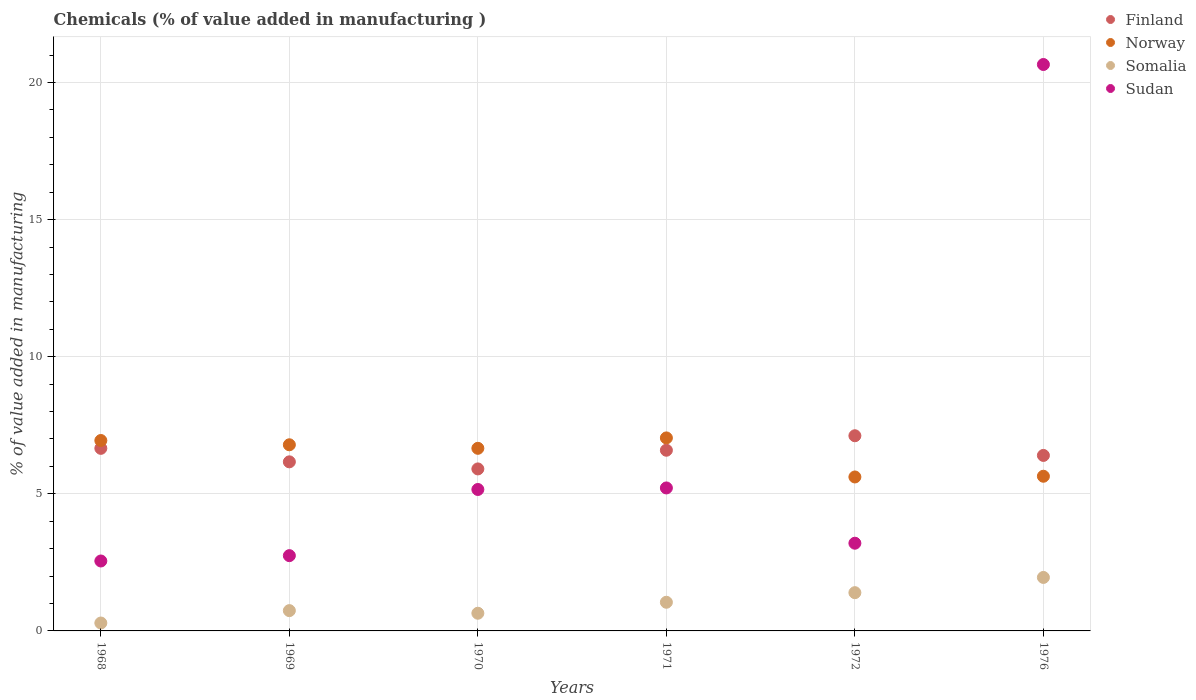How many different coloured dotlines are there?
Provide a succinct answer. 4. Is the number of dotlines equal to the number of legend labels?
Your answer should be compact. Yes. What is the value added in manufacturing chemicals in Finland in 1971?
Your answer should be very brief. 6.59. Across all years, what is the maximum value added in manufacturing chemicals in Norway?
Provide a short and direct response. 7.04. Across all years, what is the minimum value added in manufacturing chemicals in Somalia?
Give a very brief answer. 0.29. In which year was the value added in manufacturing chemicals in Somalia minimum?
Provide a short and direct response. 1968. What is the total value added in manufacturing chemicals in Sudan in the graph?
Ensure brevity in your answer.  39.53. What is the difference between the value added in manufacturing chemicals in Norway in 1970 and that in 1976?
Offer a terse response. 1.02. What is the difference between the value added in manufacturing chemicals in Somalia in 1969 and the value added in manufacturing chemicals in Finland in 1976?
Give a very brief answer. -5.66. What is the average value added in manufacturing chemicals in Finland per year?
Give a very brief answer. 6.47. In the year 1970, what is the difference between the value added in manufacturing chemicals in Finland and value added in manufacturing chemicals in Sudan?
Provide a succinct answer. 0.75. What is the ratio of the value added in manufacturing chemicals in Norway in 1968 to that in 1972?
Provide a succinct answer. 1.24. Is the value added in manufacturing chemicals in Norway in 1968 less than that in 1971?
Keep it short and to the point. Yes. Is the difference between the value added in manufacturing chemicals in Finland in 1968 and 1969 greater than the difference between the value added in manufacturing chemicals in Sudan in 1968 and 1969?
Offer a terse response. Yes. What is the difference between the highest and the second highest value added in manufacturing chemicals in Norway?
Ensure brevity in your answer.  0.09. What is the difference between the highest and the lowest value added in manufacturing chemicals in Sudan?
Make the answer very short. 18.11. Is the sum of the value added in manufacturing chemicals in Norway in 1970 and 1971 greater than the maximum value added in manufacturing chemicals in Sudan across all years?
Make the answer very short. No. Is it the case that in every year, the sum of the value added in manufacturing chemicals in Finland and value added in manufacturing chemicals in Norway  is greater than the sum of value added in manufacturing chemicals in Somalia and value added in manufacturing chemicals in Sudan?
Your response must be concise. Yes. Is it the case that in every year, the sum of the value added in manufacturing chemicals in Sudan and value added in manufacturing chemicals in Norway  is greater than the value added in manufacturing chemicals in Somalia?
Your answer should be compact. Yes. Does the value added in manufacturing chemicals in Norway monotonically increase over the years?
Keep it short and to the point. No. Is the value added in manufacturing chemicals in Sudan strictly less than the value added in manufacturing chemicals in Finland over the years?
Your response must be concise. No. How many dotlines are there?
Provide a short and direct response. 4. Does the graph contain grids?
Give a very brief answer. Yes. How many legend labels are there?
Provide a short and direct response. 4. What is the title of the graph?
Offer a terse response. Chemicals (% of value added in manufacturing ). Does "Brazil" appear as one of the legend labels in the graph?
Make the answer very short. No. What is the label or title of the X-axis?
Offer a very short reply. Years. What is the label or title of the Y-axis?
Your answer should be compact. % of value added in manufacturing. What is the % of value added in manufacturing in Finland in 1968?
Offer a very short reply. 6.66. What is the % of value added in manufacturing in Norway in 1968?
Offer a terse response. 6.94. What is the % of value added in manufacturing of Somalia in 1968?
Your response must be concise. 0.29. What is the % of value added in manufacturing in Sudan in 1968?
Ensure brevity in your answer.  2.55. What is the % of value added in manufacturing in Finland in 1969?
Make the answer very short. 6.17. What is the % of value added in manufacturing in Norway in 1969?
Your response must be concise. 6.79. What is the % of value added in manufacturing of Somalia in 1969?
Your answer should be compact. 0.74. What is the % of value added in manufacturing of Sudan in 1969?
Give a very brief answer. 2.75. What is the % of value added in manufacturing of Finland in 1970?
Provide a short and direct response. 5.91. What is the % of value added in manufacturing of Norway in 1970?
Provide a succinct answer. 6.66. What is the % of value added in manufacturing in Somalia in 1970?
Your answer should be compact. 0.64. What is the % of value added in manufacturing in Sudan in 1970?
Your answer should be very brief. 5.16. What is the % of value added in manufacturing in Finland in 1971?
Ensure brevity in your answer.  6.59. What is the % of value added in manufacturing of Norway in 1971?
Your answer should be compact. 7.04. What is the % of value added in manufacturing of Somalia in 1971?
Provide a succinct answer. 1.05. What is the % of value added in manufacturing in Sudan in 1971?
Provide a short and direct response. 5.21. What is the % of value added in manufacturing in Finland in 1972?
Keep it short and to the point. 7.12. What is the % of value added in manufacturing in Norway in 1972?
Offer a terse response. 5.61. What is the % of value added in manufacturing of Somalia in 1972?
Your response must be concise. 1.4. What is the % of value added in manufacturing in Sudan in 1972?
Offer a terse response. 3.2. What is the % of value added in manufacturing in Finland in 1976?
Provide a short and direct response. 6.4. What is the % of value added in manufacturing in Norway in 1976?
Your answer should be very brief. 5.64. What is the % of value added in manufacturing in Somalia in 1976?
Offer a very short reply. 1.95. What is the % of value added in manufacturing of Sudan in 1976?
Make the answer very short. 20.66. Across all years, what is the maximum % of value added in manufacturing in Finland?
Your response must be concise. 7.12. Across all years, what is the maximum % of value added in manufacturing of Norway?
Give a very brief answer. 7.04. Across all years, what is the maximum % of value added in manufacturing of Somalia?
Make the answer very short. 1.95. Across all years, what is the maximum % of value added in manufacturing of Sudan?
Offer a terse response. 20.66. Across all years, what is the minimum % of value added in manufacturing in Finland?
Keep it short and to the point. 5.91. Across all years, what is the minimum % of value added in manufacturing in Norway?
Your answer should be very brief. 5.61. Across all years, what is the minimum % of value added in manufacturing in Somalia?
Provide a succinct answer. 0.29. Across all years, what is the minimum % of value added in manufacturing of Sudan?
Provide a succinct answer. 2.55. What is the total % of value added in manufacturing in Finland in the graph?
Provide a succinct answer. 38.84. What is the total % of value added in manufacturing in Norway in the graph?
Your response must be concise. 38.69. What is the total % of value added in manufacturing in Somalia in the graph?
Keep it short and to the point. 6.06. What is the total % of value added in manufacturing of Sudan in the graph?
Ensure brevity in your answer.  39.53. What is the difference between the % of value added in manufacturing of Finland in 1968 and that in 1969?
Your response must be concise. 0.49. What is the difference between the % of value added in manufacturing in Norway in 1968 and that in 1969?
Your answer should be compact. 0.16. What is the difference between the % of value added in manufacturing of Somalia in 1968 and that in 1969?
Your response must be concise. -0.45. What is the difference between the % of value added in manufacturing in Sudan in 1968 and that in 1969?
Your answer should be compact. -0.19. What is the difference between the % of value added in manufacturing in Finland in 1968 and that in 1970?
Offer a terse response. 0.75. What is the difference between the % of value added in manufacturing in Norway in 1968 and that in 1970?
Your answer should be compact. 0.28. What is the difference between the % of value added in manufacturing in Somalia in 1968 and that in 1970?
Offer a very short reply. -0.36. What is the difference between the % of value added in manufacturing in Sudan in 1968 and that in 1970?
Keep it short and to the point. -2.61. What is the difference between the % of value added in manufacturing of Finland in 1968 and that in 1971?
Give a very brief answer. 0.07. What is the difference between the % of value added in manufacturing in Norway in 1968 and that in 1971?
Provide a short and direct response. -0.09. What is the difference between the % of value added in manufacturing in Somalia in 1968 and that in 1971?
Offer a very short reply. -0.76. What is the difference between the % of value added in manufacturing of Sudan in 1968 and that in 1971?
Your answer should be compact. -2.66. What is the difference between the % of value added in manufacturing of Finland in 1968 and that in 1972?
Your response must be concise. -0.46. What is the difference between the % of value added in manufacturing of Norway in 1968 and that in 1972?
Ensure brevity in your answer.  1.33. What is the difference between the % of value added in manufacturing in Somalia in 1968 and that in 1972?
Provide a succinct answer. -1.11. What is the difference between the % of value added in manufacturing in Sudan in 1968 and that in 1972?
Give a very brief answer. -0.65. What is the difference between the % of value added in manufacturing of Finland in 1968 and that in 1976?
Your answer should be compact. 0.26. What is the difference between the % of value added in manufacturing of Norway in 1968 and that in 1976?
Your answer should be compact. 1.3. What is the difference between the % of value added in manufacturing in Somalia in 1968 and that in 1976?
Your answer should be very brief. -1.66. What is the difference between the % of value added in manufacturing of Sudan in 1968 and that in 1976?
Your answer should be very brief. -18.11. What is the difference between the % of value added in manufacturing in Finland in 1969 and that in 1970?
Ensure brevity in your answer.  0.26. What is the difference between the % of value added in manufacturing in Norway in 1969 and that in 1970?
Keep it short and to the point. 0.13. What is the difference between the % of value added in manufacturing in Somalia in 1969 and that in 1970?
Ensure brevity in your answer.  0.1. What is the difference between the % of value added in manufacturing of Sudan in 1969 and that in 1970?
Make the answer very short. -2.41. What is the difference between the % of value added in manufacturing of Finland in 1969 and that in 1971?
Ensure brevity in your answer.  -0.42. What is the difference between the % of value added in manufacturing in Norway in 1969 and that in 1971?
Offer a terse response. -0.25. What is the difference between the % of value added in manufacturing in Somalia in 1969 and that in 1971?
Ensure brevity in your answer.  -0.3. What is the difference between the % of value added in manufacturing in Sudan in 1969 and that in 1971?
Keep it short and to the point. -2.47. What is the difference between the % of value added in manufacturing in Finland in 1969 and that in 1972?
Make the answer very short. -0.95. What is the difference between the % of value added in manufacturing of Norway in 1969 and that in 1972?
Provide a short and direct response. 1.17. What is the difference between the % of value added in manufacturing of Somalia in 1969 and that in 1972?
Ensure brevity in your answer.  -0.66. What is the difference between the % of value added in manufacturing of Sudan in 1969 and that in 1972?
Keep it short and to the point. -0.45. What is the difference between the % of value added in manufacturing in Finland in 1969 and that in 1976?
Your answer should be very brief. -0.23. What is the difference between the % of value added in manufacturing of Norway in 1969 and that in 1976?
Offer a very short reply. 1.15. What is the difference between the % of value added in manufacturing of Somalia in 1969 and that in 1976?
Offer a terse response. -1.21. What is the difference between the % of value added in manufacturing in Sudan in 1969 and that in 1976?
Keep it short and to the point. -17.91. What is the difference between the % of value added in manufacturing in Finland in 1970 and that in 1971?
Your answer should be compact. -0.68. What is the difference between the % of value added in manufacturing of Norway in 1970 and that in 1971?
Keep it short and to the point. -0.38. What is the difference between the % of value added in manufacturing in Somalia in 1970 and that in 1971?
Your answer should be compact. -0.4. What is the difference between the % of value added in manufacturing of Sudan in 1970 and that in 1971?
Your answer should be very brief. -0.06. What is the difference between the % of value added in manufacturing in Finland in 1970 and that in 1972?
Offer a very short reply. -1.21. What is the difference between the % of value added in manufacturing of Norway in 1970 and that in 1972?
Give a very brief answer. 1.05. What is the difference between the % of value added in manufacturing of Somalia in 1970 and that in 1972?
Ensure brevity in your answer.  -0.75. What is the difference between the % of value added in manufacturing of Sudan in 1970 and that in 1972?
Provide a succinct answer. 1.96. What is the difference between the % of value added in manufacturing of Finland in 1970 and that in 1976?
Your response must be concise. -0.49. What is the difference between the % of value added in manufacturing in Norway in 1970 and that in 1976?
Keep it short and to the point. 1.02. What is the difference between the % of value added in manufacturing in Somalia in 1970 and that in 1976?
Your response must be concise. -1.31. What is the difference between the % of value added in manufacturing of Sudan in 1970 and that in 1976?
Make the answer very short. -15.5. What is the difference between the % of value added in manufacturing in Finland in 1971 and that in 1972?
Provide a short and direct response. -0.53. What is the difference between the % of value added in manufacturing of Norway in 1971 and that in 1972?
Offer a very short reply. 1.42. What is the difference between the % of value added in manufacturing of Somalia in 1971 and that in 1972?
Provide a short and direct response. -0.35. What is the difference between the % of value added in manufacturing of Sudan in 1971 and that in 1972?
Make the answer very short. 2.02. What is the difference between the % of value added in manufacturing in Finland in 1971 and that in 1976?
Keep it short and to the point. 0.19. What is the difference between the % of value added in manufacturing in Norway in 1971 and that in 1976?
Make the answer very short. 1.4. What is the difference between the % of value added in manufacturing in Somalia in 1971 and that in 1976?
Provide a short and direct response. -0.91. What is the difference between the % of value added in manufacturing of Sudan in 1971 and that in 1976?
Make the answer very short. -15.44. What is the difference between the % of value added in manufacturing of Finland in 1972 and that in 1976?
Offer a very short reply. 0.72. What is the difference between the % of value added in manufacturing of Norway in 1972 and that in 1976?
Provide a short and direct response. -0.03. What is the difference between the % of value added in manufacturing in Somalia in 1972 and that in 1976?
Keep it short and to the point. -0.56. What is the difference between the % of value added in manufacturing of Sudan in 1972 and that in 1976?
Your answer should be compact. -17.46. What is the difference between the % of value added in manufacturing in Finland in 1968 and the % of value added in manufacturing in Norway in 1969?
Your answer should be very brief. -0.13. What is the difference between the % of value added in manufacturing of Finland in 1968 and the % of value added in manufacturing of Somalia in 1969?
Offer a very short reply. 5.92. What is the difference between the % of value added in manufacturing of Finland in 1968 and the % of value added in manufacturing of Sudan in 1969?
Your answer should be very brief. 3.91. What is the difference between the % of value added in manufacturing in Norway in 1968 and the % of value added in manufacturing in Somalia in 1969?
Give a very brief answer. 6.2. What is the difference between the % of value added in manufacturing of Norway in 1968 and the % of value added in manufacturing of Sudan in 1969?
Your answer should be compact. 4.2. What is the difference between the % of value added in manufacturing of Somalia in 1968 and the % of value added in manufacturing of Sudan in 1969?
Make the answer very short. -2.46. What is the difference between the % of value added in manufacturing of Finland in 1968 and the % of value added in manufacturing of Norway in 1970?
Ensure brevity in your answer.  -0. What is the difference between the % of value added in manufacturing of Finland in 1968 and the % of value added in manufacturing of Somalia in 1970?
Ensure brevity in your answer.  6.01. What is the difference between the % of value added in manufacturing of Finland in 1968 and the % of value added in manufacturing of Sudan in 1970?
Your response must be concise. 1.5. What is the difference between the % of value added in manufacturing of Norway in 1968 and the % of value added in manufacturing of Somalia in 1970?
Provide a succinct answer. 6.3. What is the difference between the % of value added in manufacturing in Norway in 1968 and the % of value added in manufacturing in Sudan in 1970?
Provide a succinct answer. 1.79. What is the difference between the % of value added in manufacturing in Somalia in 1968 and the % of value added in manufacturing in Sudan in 1970?
Provide a succinct answer. -4.87. What is the difference between the % of value added in manufacturing in Finland in 1968 and the % of value added in manufacturing in Norway in 1971?
Offer a very short reply. -0.38. What is the difference between the % of value added in manufacturing in Finland in 1968 and the % of value added in manufacturing in Somalia in 1971?
Make the answer very short. 5.61. What is the difference between the % of value added in manufacturing of Finland in 1968 and the % of value added in manufacturing of Sudan in 1971?
Ensure brevity in your answer.  1.44. What is the difference between the % of value added in manufacturing in Norway in 1968 and the % of value added in manufacturing in Somalia in 1971?
Make the answer very short. 5.9. What is the difference between the % of value added in manufacturing in Norway in 1968 and the % of value added in manufacturing in Sudan in 1971?
Offer a very short reply. 1.73. What is the difference between the % of value added in manufacturing in Somalia in 1968 and the % of value added in manufacturing in Sudan in 1971?
Provide a short and direct response. -4.93. What is the difference between the % of value added in manufacturing in Finland in 1968 and the % of value added in manufacturing in Norway in 1972?
Give a very brief answer. 1.04. What is the difference between the % of value added in manufacturing in Finland in 1968 and the % of value added in manufacturing in Somalia in 1972?
Offer a very short reply. 5.26. What is the difference between the % of value added in manufacturing of Finland in 1968 and the % of value added in manufacturing of Sudan in 1972?
Your answer should be compact. 3.46. What is the difference between the % of value added in manufacturing of Norway in 1968 and the % of value added in manufacturing of Somalia in 1972?
Provide a succinct answer. 5.55. What is the difference between the % of value added in manufacturing in Norway in 1968 and the % of value added in manufacturing in Sudan in 1972?
Offer a terse response. 3.75. What is the difference between the % of value added in manufacturing in Somalia in 1968 and the % of value added in manufacturing in Sudan in 1972?
Keep it short and to the point. -2.91. What is the difference between the % of value added in manufacturing in Finland in 1968 and the % of value added in manufacturing in Norway in 1976?
Offer a very short reply. 1.02. What is the difference between the % of value added in manufacturing of Finland in 1968 and the % of value added in manufacturing of Somalia in 1976?
Give a very brief answer. 4.71. What is the difference between the % of value added in manufacturing of Finland in 1968 and the % of value added in manufacturing of Sudan in 1976?
Your answer should be very brief. -14. What is the difference between the % of value added in manufacturing in Norway in 1968 and the % of value added in manufacturing in Somalia in 1976?
Give a very brief answer. 4.99. What is the difference between the % of value added in manufacturing in Norway in 1968 and the % of value added in manufacturing in Sudan in 1976?
Offer a terse response. -13.71. What is the difference between the % of value added in manufacturing in Somalia in 1968 and the % of value added in manufacturing in Sudan in 1976?
Keep it short and to the point. -20.37. What is the difference between the % of value added in manufacturing of Finland in 1969 and the % of value added in manufacturing of Norway in 1970?
Give a very brief answer. -0.49. What is the difference between the % of value added in manufacturing in Finland in 1969 and the % of value added in manufacturing in Somalia in 1970?
Give a very brief answer. 5.52. What is the difference between the % of value added in manufacturing of Norway in 1969 and the % of value added in manufacturing of Somalia in 1970?
Your answer should be very brief. 6.14. What is the difference between the % of value added in manufacturing in Norway in 1969 and the % of value added in manufacturing in Sudan in 1970?
Your answer should be very brief. 1.63. What is the difference between the % of value added in manufacturing in Somalia in 1969 and the % of value added in manufacturing in Sudan in 1970?
Give a very brief answer. -4.42. What is the difference between the % of value added in manufacturing in Finland in 1969 and the % of value added in manufacturing in Norway in 1971?
Provide a short and direct response. -0.87. What is the difference between the % of value added in manufacturing in Finland in 1969 and the % of value added in manufacturing in Somalia in 1971?
Give a very brief answer. 5.12. What is the difference between the % of value added in manufacturing in Finland in 1969 and the % of value added in manufacturing in Sudan in 1971?
Ensure brevity in your answer.  0.95. What is the difference between the % of value added in manufacturing in Norway in 1969 and the % of value added in manufacturing in Somalia in 1971?
Offer a terse response. 5.74. What is the difference between the % of value added in manufacturing in Norway in 1969 and the % of value added in manufacturing in Sudan in 1971?
Offer a very short reply. 1.57. What is the difference between the % of value added in manufacturing of Somalia in 1969 and the % of value added in manufacturing of Sudan in 1971?
Offer a terse response. -4.47. What is the difference between the % of value added in manufacturing in Finland in 1969 and the % of value added in manufacturing in Norway in 1972?
Offer a very short reply. 0.55. What is the difference between the % of value added in manufacturing in Finland in 1969 and the % of value added in manufacturing in Somalia in 1972?
Ensure brevity in your answer.  4.77. What is the difference between the % of value added in manufacturing of Finland in 1969 and the % of value added in manufacturing of Sudan in 1972?
Provide a short and direct response. 2.97. What is the difference between the % of value added in manufacturing of Norway in 1969 and the % of value added in manufacturing of Somalia in 1972?
Make the answer very short. 5.39. What is the difference between the % of value added in manufacturing in Norway in 1969 and the % of value added in manufacturing in Sudan in 1972?
Ensure brevity in your answer.  3.59. What is the difference between the % of value added in manufacturing of Somalia in 1969 and the % of value added in manufacturing of Sudan in 1972?
Your answer should be very brief. -2.46. What is the difference between the % of value added in manufacturing in Finland in 1969 and the % of value added in manufacturing in Norway in 1976?
Your answer should be very brief. 0.53. What is the difference between the % of value added in manufacturing of Finland in 1969 and the % of value added in manufacturing of Somalia in 1976?
Make the answer very short. 4.22. What is the difference between the % of value added in manufacturing of Finland in 1969 and the % of value added in manufacturing of Sudan in 1976?
Ensure brevity in your answer.  -14.49. What is the difference between the % of value added in manufacturing of Norway in 1969 and the % of value added in manufacturing of Somalia in 1976?
Your answer should be very brief. 4.84. What is the difference between the % of value added in manufacturing in Norway in 1969 and the % of value added in manufacturing in Sudan in 1976?
Give a very brief answer. -13.87. What is the difference between the % of value added in manufacturing of Somalia in 1969 and the % of value added in manufacturing of Sudan in 1976?
Provide a short and direct response. -19.92. What is the difference between the % of value added in manufacturing of Finland in 1970 and the % of value added in manufacturing of Norway in 1971?
Make the answer very short. -1.13. What is the difference between the % of value added in manufacturing of Finland in 1970 and the % of value added in manufacturing of Somalia in 1971?
Provide a succinct answer. 4.86. What is the difference between the % of value added in manufacturing in Finland in 1970 and the % of value added in manufacturing in Sudan in 1971?
Provide a succinct answer. 0.69. What is the difference between the % of value added in manufacturing in Norway in 1970 and the % of value added in manufacturing in Somalia in 1971?
Offer a very short reply. 5.61. What is the difference between the % of value added in manufacturing in Norway in 1970 and the % of value added in manufacturing in Sudan in 1971?
Your answer should be very brief. 1.45. What is the difference between the % of value added in manufacturing of Somalia in 1970 and the % of value added in manufacturing of Sudan in 1971?
Keep it short and to the point. -4.57. What is the difference between the % of value added in manufacturing in Finland in 1970 and the % of value added in manufacturing in Norway in 1972?
Ensure brevity in your answer.  0.29. What is the difference between the % of value added in manufacturing of Finland in 1970 and the % of value added in manufacturing of Somalia in 1972?
Your answer should be very brief. 4.51. What is the difference between the % of value added in manufacturing of Finland in 1970 and the % of value added in manufacturing of Sudan in 1972?
Ensure brevity in your answer.  2.71. What is the difference between the % of value added in manufacturing of Norway in 1970 and the % of value added in manufacturing of Somalia in 1972?
Offer a very short reply. 5.26. What is the difference between the % of value added in manufacturing of Norway in 1970 and the % of value added in manufacturing of Sudan in 1972?
Make the answer very short. 3.46. What is the difference between the % of value added in manufacturing in Somalia in 1970 and the % of value added in manufacturing in Sudan in 1972?
Ensure brevity in your answer.  -2.55. What is the difference between the % of value added in manufacturing in Finland in 1970 and the % of value added in manufacturing in Norway in 1976?
Ensure brevity in your answer.  0.27. What is the difference between the % of value added in manufacturing of Finland in 1970 and the % of value added in manufacturing of Somalia in 1976?
Your response must be concise. 3.96. What is the difference between the % of value added in manufacturing of Finland in 1970 and the % of value added in manufacturing of Sudan in 1976?
Provide a succinct answer. -14.75. What is the difference between the % of value added in manufacturing in Norway in 1970 and the % of value added in manufacturing in Somalia in 1976?
Ensure brevity in your answer.  4.71. What is the difference between the % of value added in manufacturing in Norway in 1970 and the % of value added in manufacturing in Sudan in 1976?
Provide a short and direct response. -14. What is the difference between the % of value added in manufacturing of Somalia in 1970 and the % of value added in manufacturing of Sudan in 1976?
Your response must be concise. -20.01. What is the difference between the % of value added in manufacturing of Finland in 1971 and the % of value added in manufacturing of Somalia in 1972?
Provide a short and direct response. 5.19. What is the difference between the % of value added in manufacturing in Finland in 1971 and the % of value added in manufacturing in Sudan in 1972?
Your response must be concise. 3.39. What is the difference between the % of value added in manufacturing in Norway in 1971 and the % of value added in manufacturing in Somalia in 1972?
Your answer should be compact. 5.64. What is the difference between the % of value added in manufacturing of Norway in 1971 and the % of value added in manufacturing of Sudan in 1972?
Make the answer very short. 3.84. What is the difference between the % of value added in manufacturing of Somalia in 1971 and the % of value added in manufacturing of Sudan in 1972?
Provide a short and direct response. -2.15. What is the difference between the % of value added in manufacturing in Finland in 1971 and the % of value added in manufacturing in Norway in 1976?
Offer a very short reply. 0.95. What is the difference between the % of value added in manufacturing in Finland in 1971 and the % of value added in manufacturing in Somalia in 1976?
Your response must be concise. 4.64. What is the difference between the % of value added in manufacturing in Finland in 1971 and the % of value added in manufacturing in Sudan in 1976?
Make the answer very short. -14.07. What is the difference between the % of value added in manufacturing in Norway in 1971 and the % of value added in manufacturing in Somalia in 1976?
Make the answer very short. 5.09. What is the difference between the % of value added in manufacturing of Norway in 1971 and the % of value added in manufacturing of Sudan in 1976?
Keep it short and to the point. -13.62. What is the difference between the % of value added in manufacturing of Somalia in 1971 and the % of value added in manufacturing of Sudan in 1976?
Offer a very short reply. -19.61. What is the difference between the % of value added in manufacturing in Finland in 1972 and the % of value added in manufacturing in Norway in 1976?
Provide a short and direct response. 1.48. What is the difference between the % of value added in manufacturing of Finland in 1972 and the % of value added in manufacturing of Somalia in 1976?
Provide a short and direct response. 5.17. What is the difference between the % of value added in manufacturing in Finland in 1972 and the % of value added in manufacturing in Sudan in 1976?
Provide a short and direct response. -13.54. What is the difference between the % of value added in manufacturing in Norway in 1972 and the % of value added in manufacturing in Somalia in 1976?
Offer a terse response. 3.66. What is the difference between the % of value added in manufacturing of Norway in 1972 and the % of value added in manufacturing of Sudan in 1976?
Ensure brevity in your answer.  -15.04. What is the difference between the % of value added in manufacturing in Somalia in 1972 and the % of value added in manufacturing in Sudan in 1976?
Your answer should be very brief. -19.26. What is the average % of value added in manufacturing in Finland per year?
Offer a terse response. 6.47. What is the average % of value added in manufacturing of Norway per year?
Give a very brief answer. 6.45. What is the average % of value added in manufacturing of Somalia per year?
Give a very brief answer. 1.01. What is the average % of value added in manufacturing in Sudan per year?
Provide a succinct answer. 6.59. In the year 1968, what is the difference between the % of value added in manufacturing in Finland and % of value added in manufacturing in Norway?
Your response must be concise. -0.29. In the year 1968, what is the difference between the % of value added in manufacturing of Finland and % of value added in manufacturing of Somalia?
Make the answer very short. 6.37. In the year 1968, what is the difference between the % of value added in manufacturing of Finland and % of value added in manufacturing of Sudan?
Ensure brevity in your answer.  4.11. In the year 1968, what is the difference between the % of value added in manufacturing of Norway and % of value added in manufacturing of Somalia?
Provide a succinct answer. 6.66. In the year 1968, what is the difference between the % of value added in manufacturing in Norway and % of value added in manufacturing in Sudan?
Provide a short and direct response. 4.39. In the year 1968, what is the difference between the % of value added in manufacturing in Somalia and % of value added in manufacturing in Sudan?
Give a very brief answer. -2.26. In the year 1969, what is the difference between the % of value added in manufacturing of Finland and % of value added in manufacturing of Norway?
Offer a terse response. -0.62. In the year 1969, what is the difference between the % of value added in manufacturing of Finland and % of value added in manufacturing of Somalia?
Your response must be concise. 5.43. In the year 1969, what is the difference between the % of value added in manufacturing in Finland and % of value added in manufacturing in Sudan?
Provide a short and direct response. 3.42. In the year 1969, what is the difference between the % of value added in manufacturing of Norway and % of value added in manufacturing of Somalia?
Your response must be concise. 6.05. In the year 1969, what is the difference between the % of value added in manufacturing in Norway and % of value added in manufacturing in Sudan?
Make the answer very short. 4.04. In the year 1969, what is the difference between the % of value added in manufacturing of Somalia and % of value added in manufacturing of Sudan?
Provide a succinct answer. -2.01. In the year 1970, what is the difference between the % of value added in manufacturing in Finland and % of value added in manufacturing in Norway?
Ensure brevity in your answer.  -0.75. In the year 1970, what is the difference between the % of value added in manufacturing of Finland and % of value added in manufacturing of Somalia?
Give a very brief answer. 5.26. In the year 1970, what is the difference between the % of value added in manufacturing in Finland and % of value added in manufacturing in Sudan?
Your answer should be very brief. 0.75. In the year 1970, what is the difference between the % of value added in manufacturing in Norway and % of value added in manufacturing in Somalia?
Your response must be concise. 6.01. In the year 1970, what is the difference between the % of value added in manufacturing of Norway and % of value added in manufacturing of Sudan?
Provide a short and direct response. 1.5. In the year 1970, what is the difference between the % of value added in manufacturing of Somalia and % of value added in manufacturing of Sudan?
Make the answer very short. -4.51. In the year 1971, what is the difference between the % of value added in manufacturing of Finland and % of value added in manufacturing of Norway?
Give a very brief answer. -0.45. In the year 1971, what is the difference between the % of value added in manufacturing of Finland and % of value added in manufacturing of Somalia?
Your answer should be compact. 5.54. In the year 1971, what is the difference between the % of value added in manufacturing in Finland and % of value added in manufacturing in Sudan?
Give a very brief answer. 1.38. In the year 1971, what is the difference between the % of value added in manufacturing in Norway and % of value added in manufacturing in Somalia?
Your answer should be very brief. 5.99. In the year 1971, what is the difference between the % of value added in manufacturing of Norway and % of value added in manufacturing of Sudan?
Provide a succinct answer. 1.82. In the year 1971, what is the difference between the % of value added in manufacturing of Somalia and % of value added in manufacturing of Sudan?
Give a very brief answer. -4.17. In the year 1972, what is the difference between the % of value added in manufacturing in Finland and % of value added in manufacturing in Norway?
Your response must be concise. 1.5. In the year 1972, what is the difference between the % of value added in manufacturing in Finland and % of value added in manufacturing in Somalia?
Your response must be concise. 5.72. In the year 1972, what is the difference between the % of value added in manufacturing in Finland and % of value added in manufacturing in Sudan?
Offer a terse response. 3.92. In the year 1972, what is the difference between the % of value added in manufacturing in Norway and % of value added in manufacturing in Somalia?
Ensure brevity in your answer.  4.22. In the year 1972, what is the difference between the % of value added in manufacturing in Norway and % of value added in manufacturing in Sudan?
Make the answer very short. 2.42. In the year 1972, what is the difference between the % of value added in manufacturing of Somalia and % of value added in manufacturing of Sudan?
Your response must be concise. -1.8. In the year 1976, what is the difference between the % of value added in manufacturing of Finland and % of value added in manufacturing of Norway?
Your answer should be compact. 0.76. In the year 1976, what is the difference between the % of value added in manufacturing of Finland and % of value added in manufacturing of Somalia?
Offer a very short reply. 4.45. In the year 1976, what is the difference between the % of value added in manufacturing in Finland and % of value added in manufacturing in Sudan?
Your answer should be very brief. -14.26. In the year 1976, what is the difference between the % of value added in manufacturing of Norway and % of value added in manufacturing of Somalia?
Your answer should be very brief. 3.69. In the year 1976, what is the difference between the % of value added in manufacturing of Norway and % of value added in manufacturing of Sudan?
Provide a succinct answer. -15.02. In the year 1976, what is the difference between the % of value added in manufacturing in Somalia and % of value added in manufacturing in Sudan?
Your answer should be very brief. -18.71. What is the ratio of the % of value added in manufacturing of Finland in 1968 to that in 1969?
Provide a succinct answer. 1.08. What is the ratio of the % of value added in manufacturing in Norway in 1968 to that in 1969?
Provide a short and direct response. 1.02. What is the ratio of the % of value added in manufacturing of Somalia in 1968 to that in 1969?
Give a very brief answer. 0.39. What is the ratio of the % of value added in manufacturing in Sudan in 1968 to that in 1969?
Provide a succinct answer. 0.93. What is the ratio of the % of value added in manufacturing in Finland in 1968 to that in 1970?
Make the answer very short. 1.13. What is the ratio of the % of value added in manufacturing in Norway in 1968 to that in 1970?
Provide a succinct answer. 1.04. What is the ratio of the % of value added in manufacturing in Somalia in 1968 to that in 1970?
Ensure brevity in your answer.  0.45. What is the ratio of the % of value added in manufacturing of Sudan in 1968 to that in 1970?
Provide a short and direct response. 0.49. What is the ratio of the % of value added in manufacturing of Finland in 1968 to that in 1971?
Ensure brevity in your answer.  1.01. What is the ratio of the % of value added in manufacturing of Norway in 1968 to that in 1971?
Offer a very short reply. 0.99. What is the ratio of the % of value added in manufacturing of Somalia in 1968 to that in 1971?
Make the answer very short. 0.28. What is the ratio of the % of value added in manufacturing of Sudan in 1968 to that in 1971?
Your answer should be compact. 0.49. What is the ratio of the % of value added in manufacturing in Finland in 1968 to that in 1972?
Your answer should be very brief. 0.94. What is the ratio of the % of value added in manufacturing in Norway in 1968 to that in 1972?
Make the answer very short. 1.24. What is the ratio of the % of value added in manufacturing of Somalia in 1968 to that in 1972?
Provide a succinct answer. 0.21. What is the ratio of the % of value added in manufacturing of Sudan in 1968 to that in 1972?
Provide a short and direct response. 0.8. What is the ratio of the % of value added in manufacturing of Finland in 1968 to that in 1976?
Provide a succinct answer. 1.04. What is the ratio of the % of value added in manufacturing of Norway in 1968 to that in 1976?
Your response must be concise. 1.23. What is the ratio of the % of value added in manufacturing of Somalia in 1968 to that in 1976?
Offer a very short reply. 0.15. What is the ratio of the % of value added in manufacturing of Sudan in 1968 to that in 1976?
Provide a short and direct response. 0.12. What is the ratio of the % of value added in manufacturing in Finland in 1969 to that in 1970?
Your response must be concise. 1.04. What is the ratio of the % of value added in manufacturing in Norway in 1969 to that in 1970?
Make the answer very short. 1.02. What is the ratio of the % of value added in manufacturing in Somalia in 1969 to that in 1970?
Ensure brevity in your answer.  1.15. What is the ratio of the % of value added in manufacturing in Sudan in 1969 to that in 1970?
Your answer should be compact. 0.53. What is the ratio of the % of value added in manufacturing in Finland in 1969 to that in 1971?
Give a very brief answer. 0.94. What is the ratio of the % of value added in manufacturing in Norway in 1969 to that in 1971?
Provide a succinct answer. 0.96. What is the ratio of the % of value added in manufacturing of Somalia in 1969 to that in 1971?
Make the answer very short. 0.71. What is the ratio of the % of value added in manufacturing of Sudan in 1969 to that in 1971?
Ensure brevity in your answer.  0.53. What is the ratio of the % of value added in manufacturing of Finland in 1969 to that in 1972?
Keep it short and to the point. 0.87. What is the ratio of the % of value added in manufacturing in Norway in 1969 to that in 1972?
Your response must be concise. 1.21. What is the ratio of the % of value added in manufacturing in Somalia in 1969 to that in 1972?
Provide a short and direct response. 0.53. What is the ratio of the % of value added in manufacturing in Sudan in 1969 to that in 1972?
Your response must be concise. 0.86. What is the ratio of the % of value added in manufacturing in Finland in 1969 to that in 1976?
Give a very brief answer. 0.96. What is the ratio of the % of value added in manufacturing in Norway in 1969 to that in 1976?
Your answer should be very brief. 1.2. What is the ratio of the % of value added in manufacturing in Somalia in 1969 to that in 1976?
Give a very brief answer. 0.38. What is the ratio of the % of value added in manufacturing of Sudan in 1969 to that in 1976?
Provide a short and direct response. 0.13. What is the ratio of the % of value added in manufacturing of Finland in 1970 to that in 1971?
Offer a very short reply. 0.9. What is the ratio of the % of value added in manufacturing in Norway in 1970 to that in 1971?
Your response must be concise. 0.95. What is the ratio of the % of value added in manufacturing in Somalia in 1970 to that in 1971?
Offer a terse response. 0.62. What is the ratio of the % of value added in manufacturing of Sudan in 1970 to that in 1971?
Provide a short and direct response. 0.99. What is the ratio of the % of value added in manufacturing in Finland in 1970 to that in 1972?
Your answer should be compact. 0.83. What is the ratio of the % of value added in manufacturing of Norway in 1970 to that in 1972?
Offer a terse response. 1.19. What is the ratio of the % of value added in manufacturing of Somalia in 1970 to that in 1972?
Keep it short and to the point. 0.46. What is the ratio of the % of value added in manufacturing in Sudan in 1970 to that in 1972?
Provide a succinct answer. 1.61. What is the ratio of the % of value added in manufacturing in Finland in 1970 to that in 1976?
Offer a very short reply. 0.92. What is the ratio of the % of value added in manufacturing of Norway in 1970 to that in 1976?
Make the answer very short. 1.18. What is the ratio of the % of value added in manufacturing in Somalia in 1970 to that in 1976?
Make the answer very short. 0.33. What is the ratio of the % of value added in manufacturing of Sudan in 1970 to that in 1976?
Make the answer very short. 0.25. What is the ratio of the % of value added in manufacturing in Finland in 1971 to that in 1972?
Offer a very short reply. 0.93. What is the ratio of the % of value added in manufacturing of Norway in 1971 to that in 1972?
Your answer should be very brief. 1.25. What is the ratio of the % of value added in manufacturing in Somalia in 1971 to that in 1972?
Provide a succinct answer. 0.75. What is the ratio of the % of value added in manufacturing in Sudan in 1971 to that in 1972?
Offer a very short reply. 1.63. What is the ratio of the % of value added in manufacturing in Finland in 1971 to that in 1976?
Your answer should be compact. 1.03. What is the ratio of the % of value added in manufacturing in Norway in 1971 to that in 1976?
Provide a short and direct response. 1.25. What is the ratio of the % of value added in manufacturing of Somalia in 1971 to that in 1976?
Your answer should be very brief. 0.54. What is the ratio of the % of value added in manufacturing of Sudan in 1971 to that in 1976?
Provide a short and direct response. 0.25. What is the ratio of the % of value added in manufacturing in Finland in 1972 to that in 1976?
Your response must be concise. 1.11. What is the ratio of the % of value added in manufacturing of Norway in 1972 to that in 1976?
Provide a short and direct response. 1. What is the ratio of the % of value added in manufacturing of Somalia in 1972 to that in 1976?
Make the answer very short. 0.72. What is the ratio of the % of value added in manufacturing in Sudan in 1972 to that in 1976?
Give a very brief answer. 0.15. What is the difference between the highest and the second highest % of value added in manufacturing in Finland?
Provide a succinct answer. 0.46. What is the difference between the highest and the second highest % of value added in manufacturing in Norway?
Ensure brevity in your answer.  0.09. What is the difference between the highest and the second highest % of value added in manufacturing in Somalia?
Keep it short and to the point. 0.56. What is the difference between the highest and the second highest % of value added in manufacturing of Sudan?
Provide a short and direct response. 15.44. What is the difference between the highest and the lowest % of value added in manufacturing in Finland?
Ensure brevity in your answer.  1.21. What is the difference between the highest and the lowest % of value added in manufacturing of Norway?
Provide a short and direct response. 1.42. What is the difference between the highest and the lowest % of value added in manufacturing in Somalia?
Give a very brief answer. 1.66. What is the difference between the highest and the lowest % of value added in manufacturing in Sudan?
Ensure brevity in your answer.  18.11. 